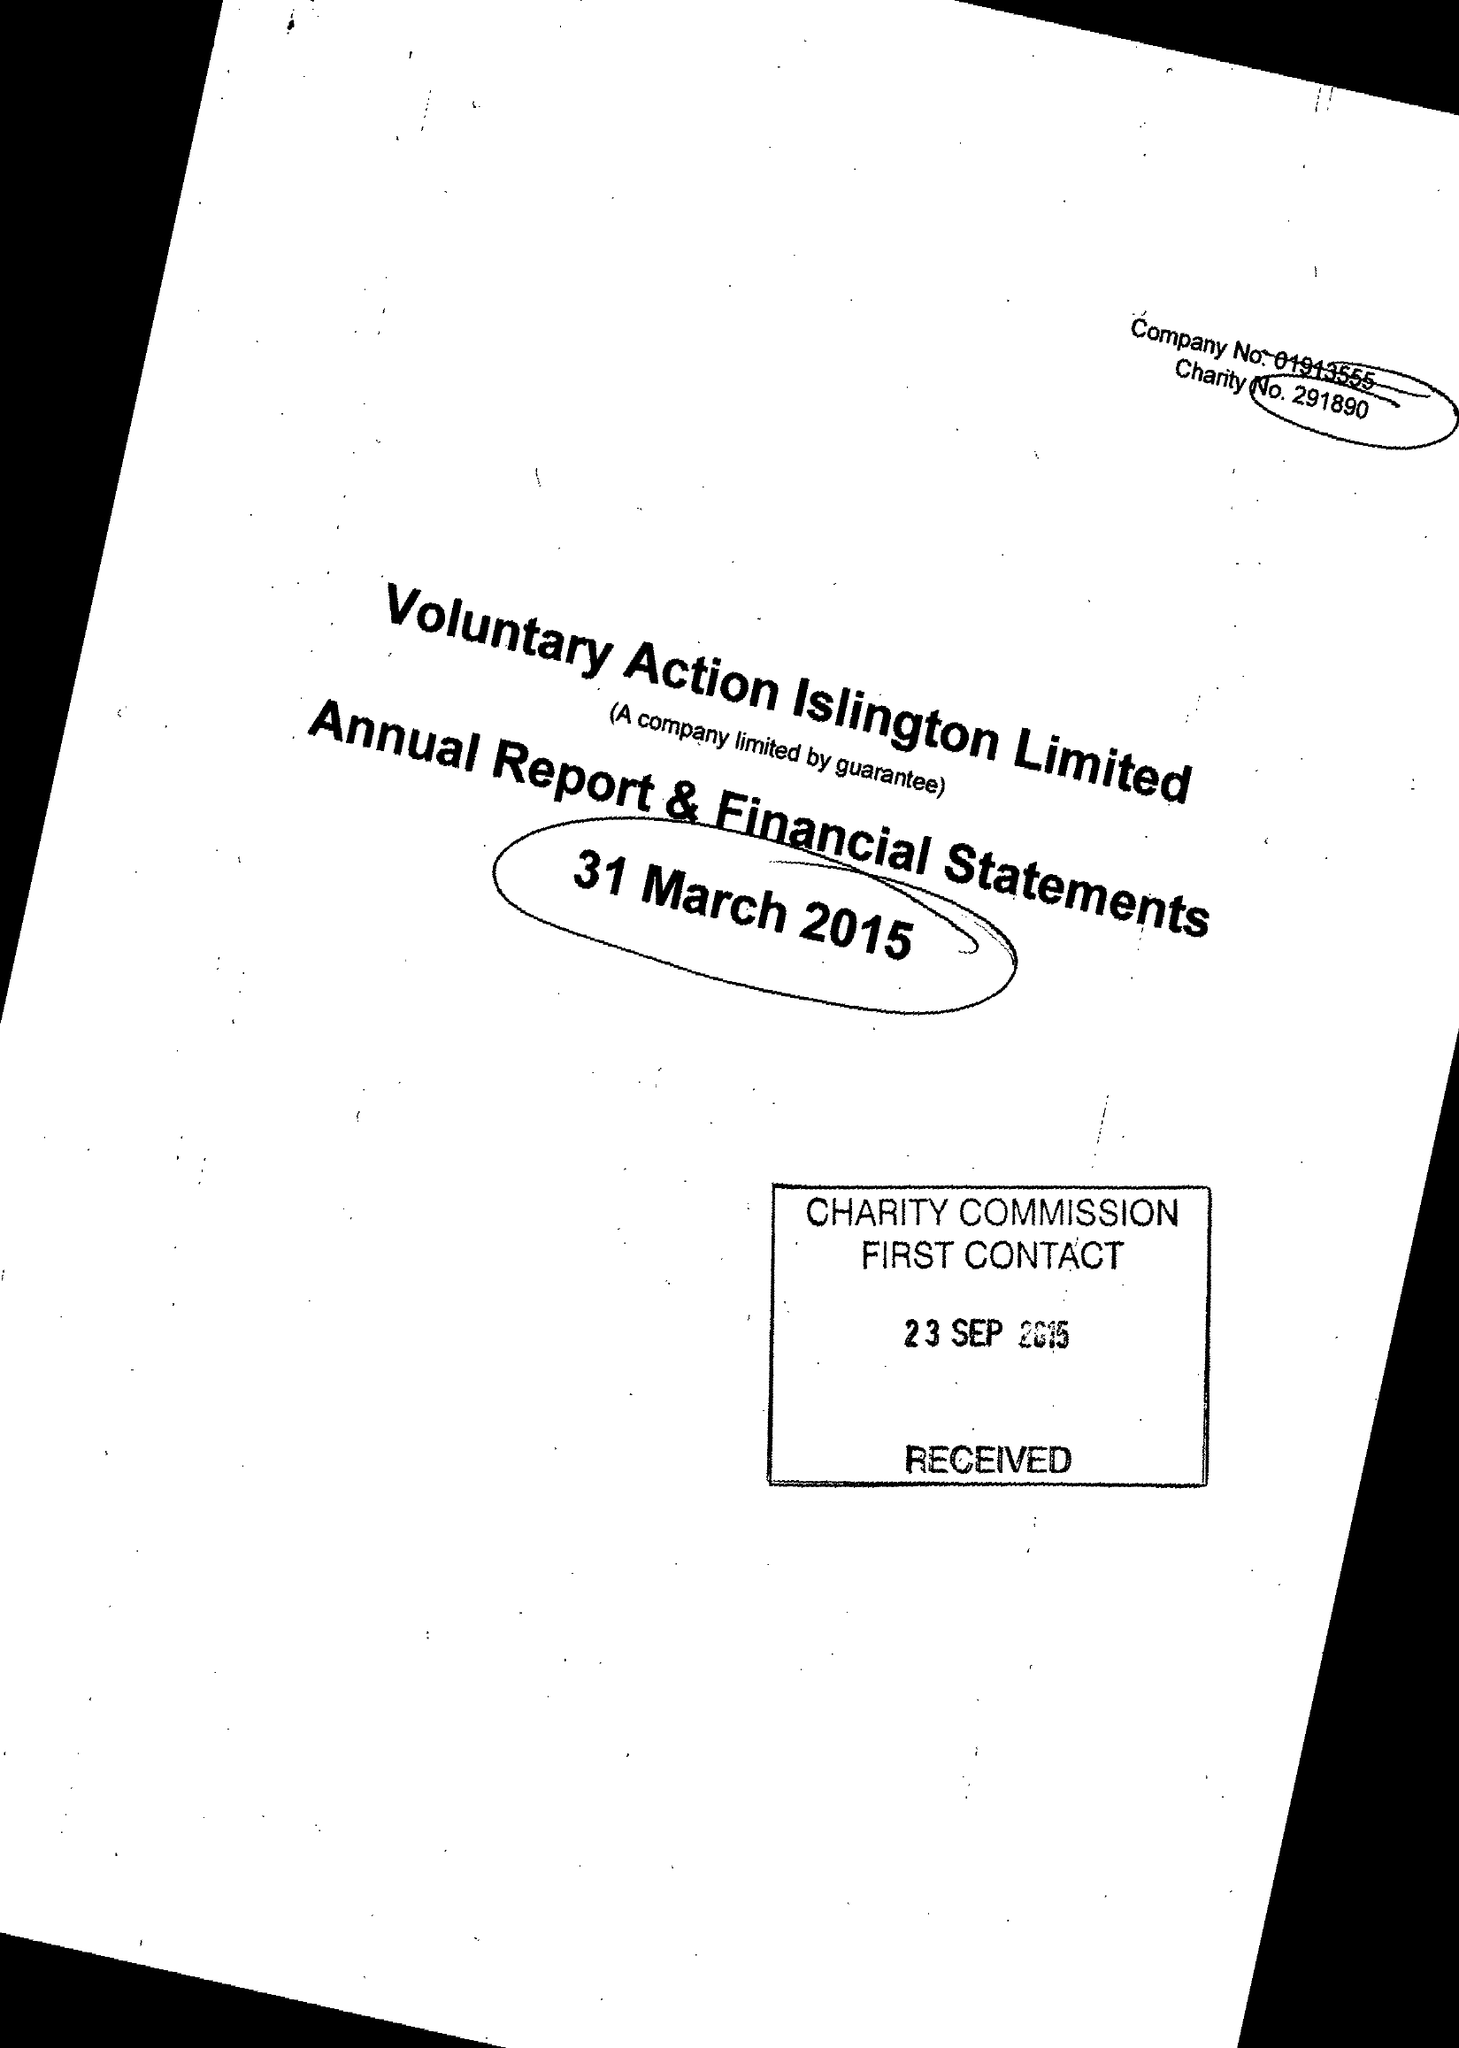What is the value for the address__postcode?
Answer the question using a single word or phrase. N1 9JP 